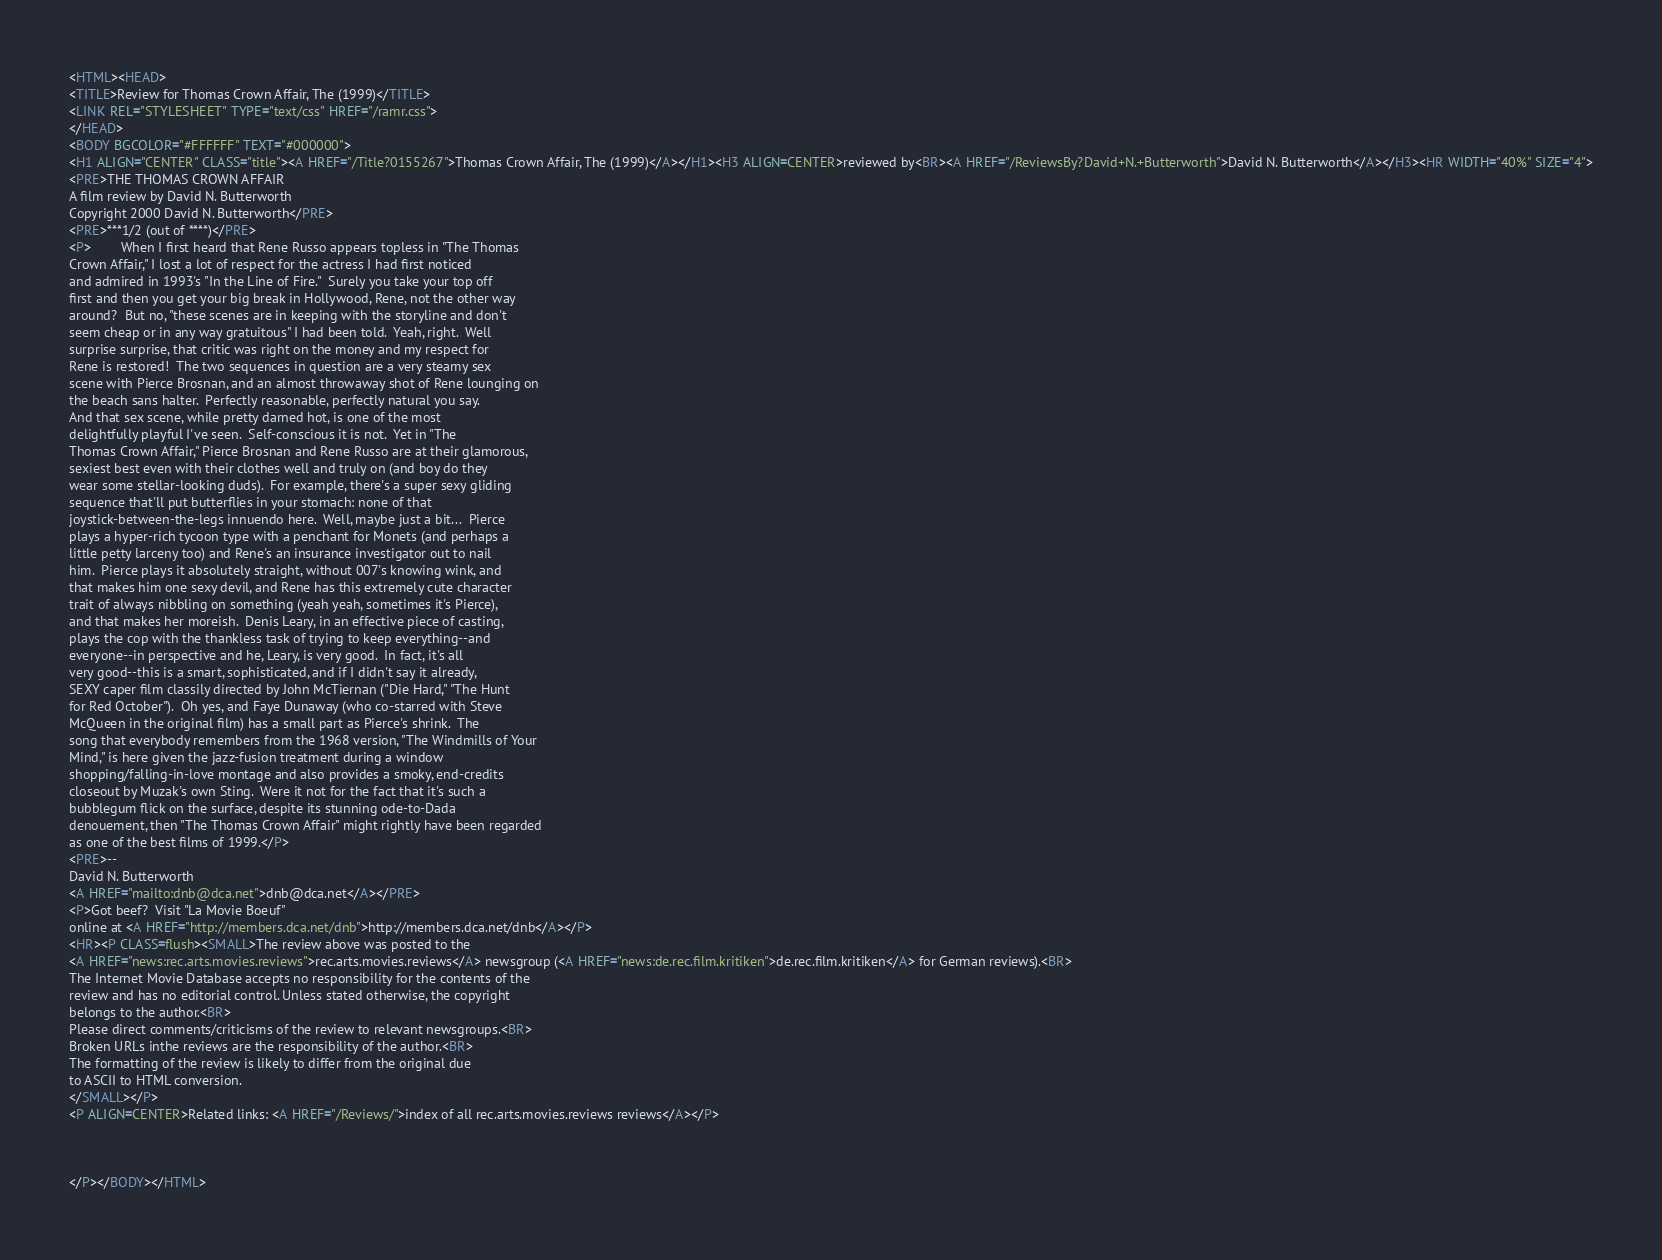<code> <loc_0><loc_0><loc_500><loc_500><_HTML_><HTML><HEAD>
<TITLE>Review for Thomas Crown Affair, The (1999)</TITLE>
<LINK REL="STYLESHEET" TYPE="text/css" HREF="/ramr.css">
</HEAD>
<BODY BGCOLOR="#FFFFFF" TEXT="#000000">
<H1 ALIGN="CENTER" CLASS="title"><A HREF="/Title?0155267">Thomas Crown Affair, The (1999)</A></H1><H3 ALIGN=CENTER>reviewed by<BR><A HREF="/ReviewsBy?David+N.+Butterworth">David N. Butterworth</A></H3><HR WIDTH="40%" SIZE="4">
<PRE>THE THOMAS CROWN AFFAIR
A film review by David N. Butterworth
Copyright 2000 David N. Butterworth</PRE>
<PRE>***1/2 (out of ****)</PRE>
<P>        When I first heard that Rene Russo appears topless in "The Thomas
Crown Affair," I lost a lot of respect for the actress I had first noticed
and admired in 1993's "In the Line of Fire."  Surely you take your top off
first and then you get your big break in Hollywood, Rene, not the other way
around?  But no, "these scenes are in keeping with the storyline and don't
seem cheap or in any way gratuitous" I had been told.  Yeah, right.  Well
surprise surprise, that critic was right on the money and my respect for
Rene is restored!  The two sequences in question are a very steamy sex
scene with Pierce Brosnan, and an almost throwaway shot of Rene lounging on
the beach sans halter.  Perfectly reasonable, perfectly natural you say.
And that sex scene, while pretty darned hot, is one of the most
delightfully playful I've seen.  Self-conscious it is not.  Yet in "The
Thomas Crown Affair," Pierce Brosnan and Rene Russo are at their glamorous,
sexiest best even with their clothes well and truly on (and boy do they
wear some stellar-looking duds).  For example, there's a super sexy gliding
sequence that'll put butterflies in your stomach: none of that
joystick-between-the-legs innuendo here.  Well, maybe just a bit...  Pierce
plays a hyper-rich tycoon type with a penchant for Monets (and perhaps a
little petty larceny too) and Rene's an insurance investigator out to nail
him.  Pierce plays it absolutely straight, without 007's knowing wink, and
that makes him one sexy devil, and Rene has this extremely cute character
trait of always nibbling on something (yeah yeah, sometimes it's Pierce),
and that makes her moreish.  Denis Leary, in an effective piece of casting,
plays the cop with the thankless task of trying to keep everything--and
everyone--in perspective and he, Leary, is very good.  In fact, it's all
very good--this is a smart, sophisticated, and if I didn't say it already,
SEXY caper film classily directed by John McTiernan ("Die Hard," "The Hunt
for Red October").  Oh yes, and Faye Dunaway (who co-starred with Steve
McQueen in the original film) has a small part as Pierce's shrink.  The
song that everybody remembers from the 1968 version, "The Windmills of Your
Mind," is here given the jazz-fusion treatment during a window
shopping/falling-in-love montage and also provides a smoky, end-credits
closeout by Muzak's own Sting.  Were it not for the fact that it's such a
bubblegum flick on the surface, despite its stunning ode-to-Dada
denouement, then "The Thomas Crown Affair" might rightly have been regarded
as one of the best films of 1999.</P>
<PRE>--
David N. Butterworth
<A HREF="mailto:dnb@dca.net">dnb@dca.net</A></PRE>
<P>Got beef?  Visit "La Movie Boeuf"
online at <A HREF="http://members.dca.net/dnb">http://members.dca.net/dnb</A></P>
<HR><P CLASS=flush><SMALL>The review above was posted to the
<A HREF="news:rec.arts.movies.reviews">rec.arts.movies.reviews</A> newsgroup (<A HREF="news:de.rec.film.kritiken">de.rec.film.kritiken</A> for German reviews).<BR>
The Internet Movie Database accepts no responsibility for the contents of the
review and has no editorial control. Unless stated otherwise, the copyright
belongs to the author.<BR>
Please direct comments/criticisms of the review to relevant newsgroups.<BR>
Broken URLs inthe reviews are the responsibility of the author.<BR>
The formatting of the review is likely to differ from the original due
to ASCII to HTML conversion.
</SMALL></P>
<P ALIGN=CENTER>Related links: <A HREF="/Reviews/">index of all rec.arts.movies.reviews reviews</A></P>



</P></BODY></HTML>
</code> 